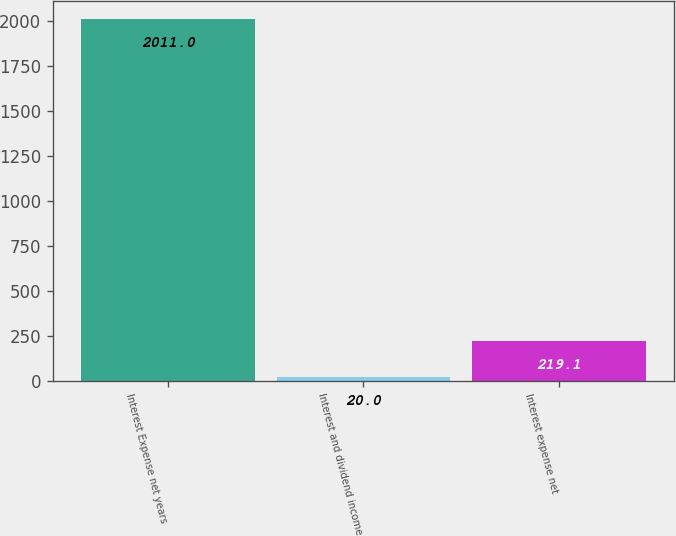Convert chart to OTSL. <chart><loc_0><loc_0><loc_500><loc_500><bar_chart><fcel>Interest Expense net years<fcel>Interest and dividend income<fcel>Interest expense net<nl><fcel>2011<fcel>20<fcel>219.1<nl></chart> 